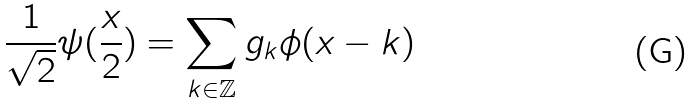Convert formula to latex. <formula><loc_0><loc_0><loc_500><loc_500>\frac { 1 } { \sqrt { 2 } } \psi ( \frac { x } { 2 } ) = \sum _ { k \in \mathbb { Z } } g _ { k } \phi ( x - k )</formula> 